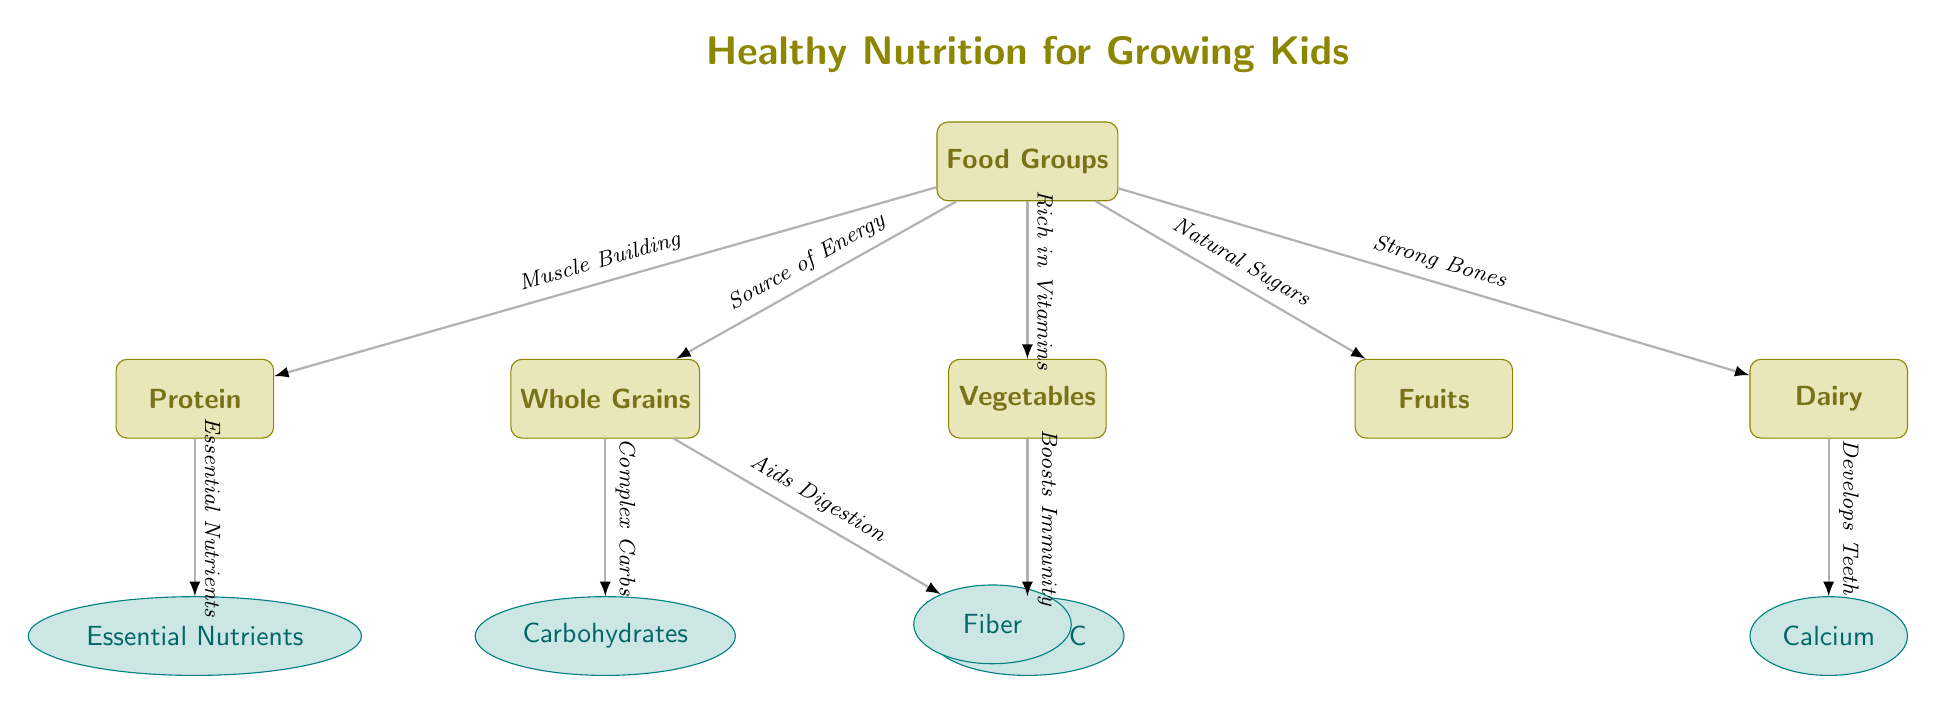What are the main food groups? The diagram lists the main food groups as Whole Grains, Vegetables, Fruits, Protein, and Dairy, which are clearly labeled in the main nodes below the "Food Groups" title.
Answer: Whole Grains, Vegetables, Fruits, Protein, Dairy What nutrient is associated with Dairy? The diagram shows that Dairy is connected to the node labeled "Calcium," indicating that calcium is the nutrient linked to dairy foods.
Answer: Calcium How many secondary nodes are there? The diagram includes five secondary nodes: Carbohydrates, Vitamin C, Calcium, Essential Nutrients, and Fiber. By counting these nodes, we determine the total.
Answer: 5 Which food group provides muscle building? The Protein node directly connects to the main Food Groups node with the label "Muscle Building," indicating its importance in that regard.
Answer: Protein What benefit do Vegetables provide according to the diagram? The edge leading from the Vegetables node points to the secondary node labeled "Vitamin C," which indicates that vegetables are rich in this important vitamin, hence boosting immunity as stated in the description.
Answer: Boosts Immunity What is the connection between Whole Grains and Carbohydrates? The edge between the Whole Grains node and Carbohydrates shows that Whole Grains provide "Complex Carbs," which indicates the nature of carbohydrates derived from them.
Answer: Complex Carbs What do Whole Grains and Protein have in common concerning nutrient provision? Both Whole Grains and Protein connect to their respective secondary nodes (Carbohydrates and Essential Nutrients), indicating that they both provide vital nutrient categories for growth and health.
Answer: Nutritional Benefits What does the title of the diagram emphasize? The title "Healthy Nutrition for Growing Kids" emphasizes the focus on nutritional needs essential for the health and development of children, capturing the overall theme of the diagram.
Answer: Healthy Nutrition for Growing Kids What nutrient is linked to the Protein food group? The Protein node is connected to the secondary node labeled "Essential Nutrients," indicating that it provides critical nutrients required for growth and development.
Answer: Essential Nutrients 